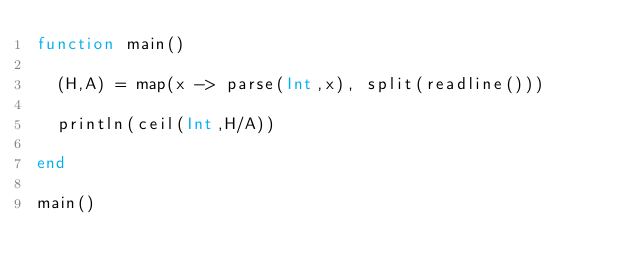<code> <loc_0><loc_0><loc_500><loc_500><_Julia_>function main()
  
  (H,A) = map(x -> parse(Int,x), split(readline()))
  
  println(ceil(Int,H/A))
  
end

main()</code> 